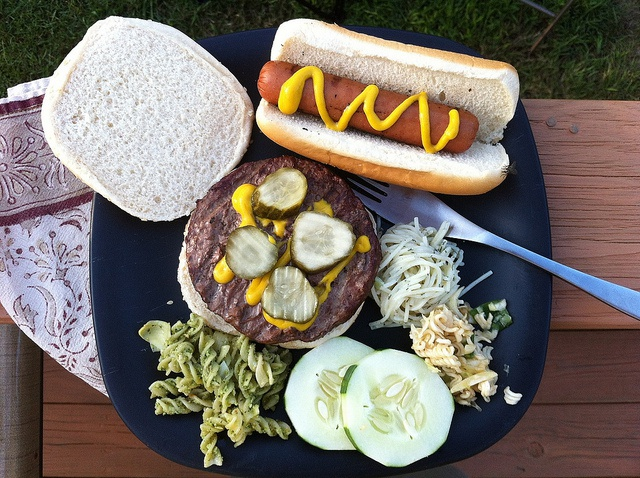Describe the objects in this image and their specific colors. I can see sandwich in darkgreen, lightgray, darkgray, maroon, and brown tones, dining table in darkgreen, maroon, gray, and brown tones, hot dog in darkgreen, ivory, tan, brown, and orange tones, and fork in darkgreen, lightblue, purple, black, and gray tones in this image. 